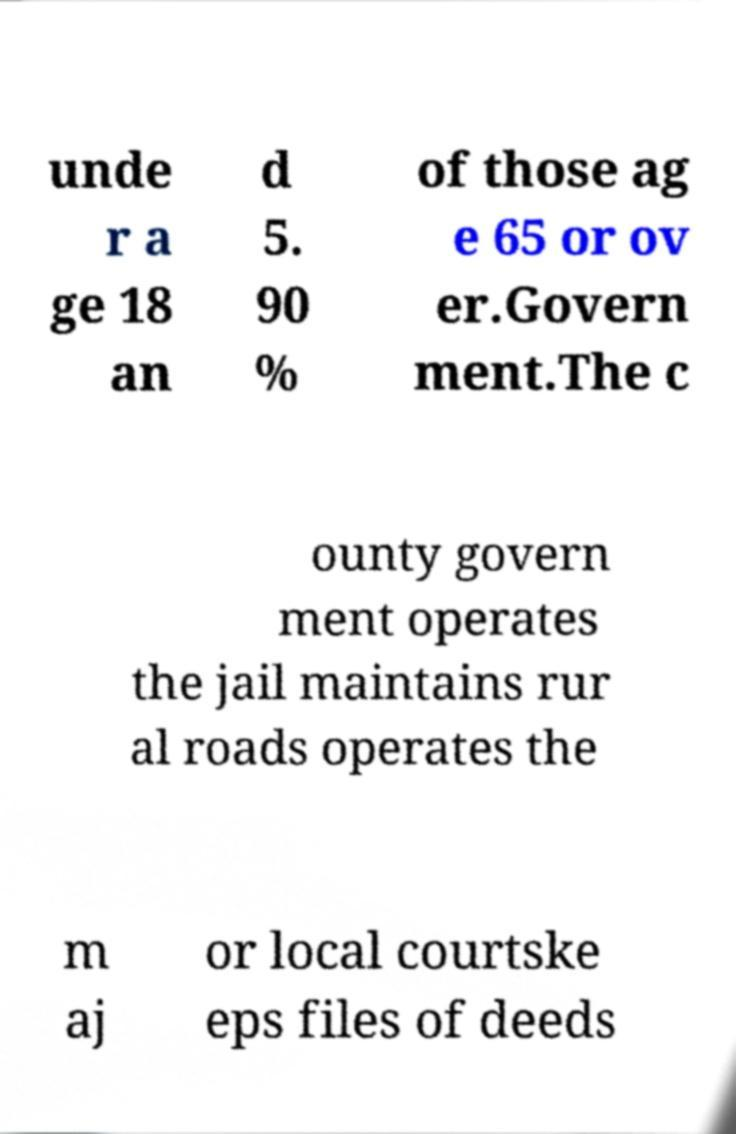What messages or text are displayed in this image? I need them in a readable, typed format. unde r a ge 18 an d 5. 90 % of those ag e 65 or ov er.Govern ment.The c ounty govern ment operates the jail maintains rur al roads operates the m aj or local courtske eps files of deeds 